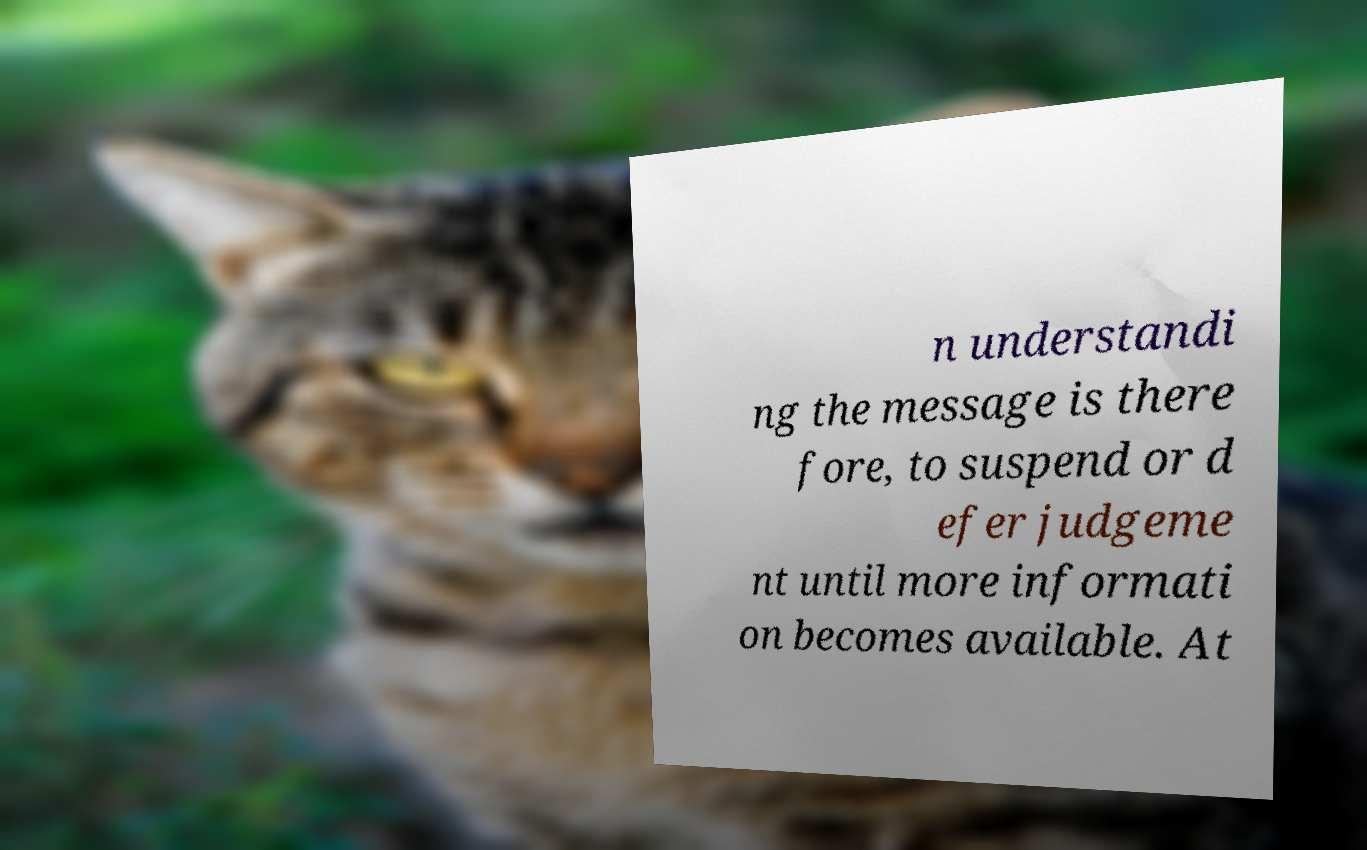Please identify and transcribe the text found in this image. n understandi ng the message is there fore, to suspend or d efer judgeme nt until more informati on becomes available. At 